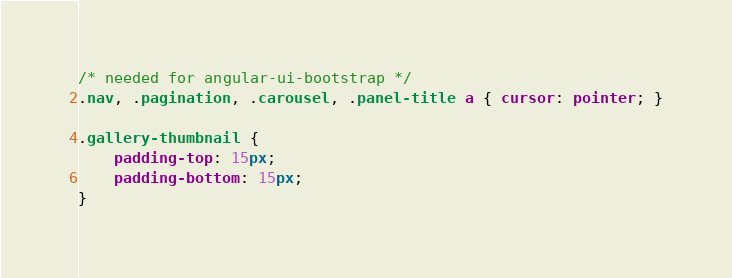Convert code to text. <code><loc_0><loc_0><loc_500><loc_500><_CSS_>/* needed for angular-ui-bootstrap */
.nav, .pagination, .carousel, .panel-title a { cursor: pointer; }

.gallery-thumbnail {
	padding-top: 15px;
	padding-bottom: 15px;
}</code> 